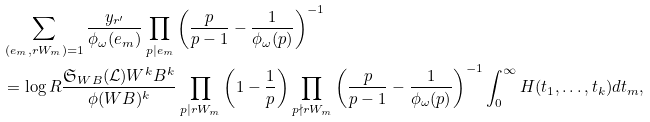Convert formula to latex. <formula><loc_0><loc_0><loc_500><loc_500>& \sum _ { ( e _ { m } , r W _ { m } ) = 1 } \frac { y _ { r ^ { \prime } } } { \phi _ { \omega } ( e _ { m } ) } \prod _ { p | e _ { m } } \left ( \frac { p } { p - 1 } - \frac { 1 } { \phi _ { \omega } ( p ) } \right ) ^ { - 1 } \\ & = \log { R } \frac { \mathfrak { S } _ { W B } ( \mathcal { L } ) W ^ { k } B ^ { k } } { \phi ( W B ) ^ { k } } \prod _ { p | r W _ { m } } \left ( 1 - \frac { 1 } { p } \right ) \prod _ { p \nmid r W _ { m } } \left ( \frac { p } { p - 1 } - \frac { 1 } { \phi _ { \omega } ( p ) } \right ) ^ { - 1 } \int _ { 0 } ^ { \infty } H ( t _ { 1 } , \dots , t _ { k } ) d t _ { m } ,</formula> 